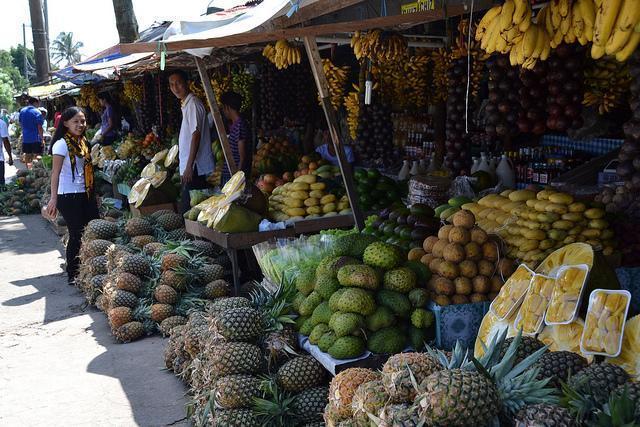How many people are looking toward the camera?
Give a very brief answer. 2. How many bananas are there?
Give a very brief answer. 3. How many people are visible?
Give a very brief answer. 2. 